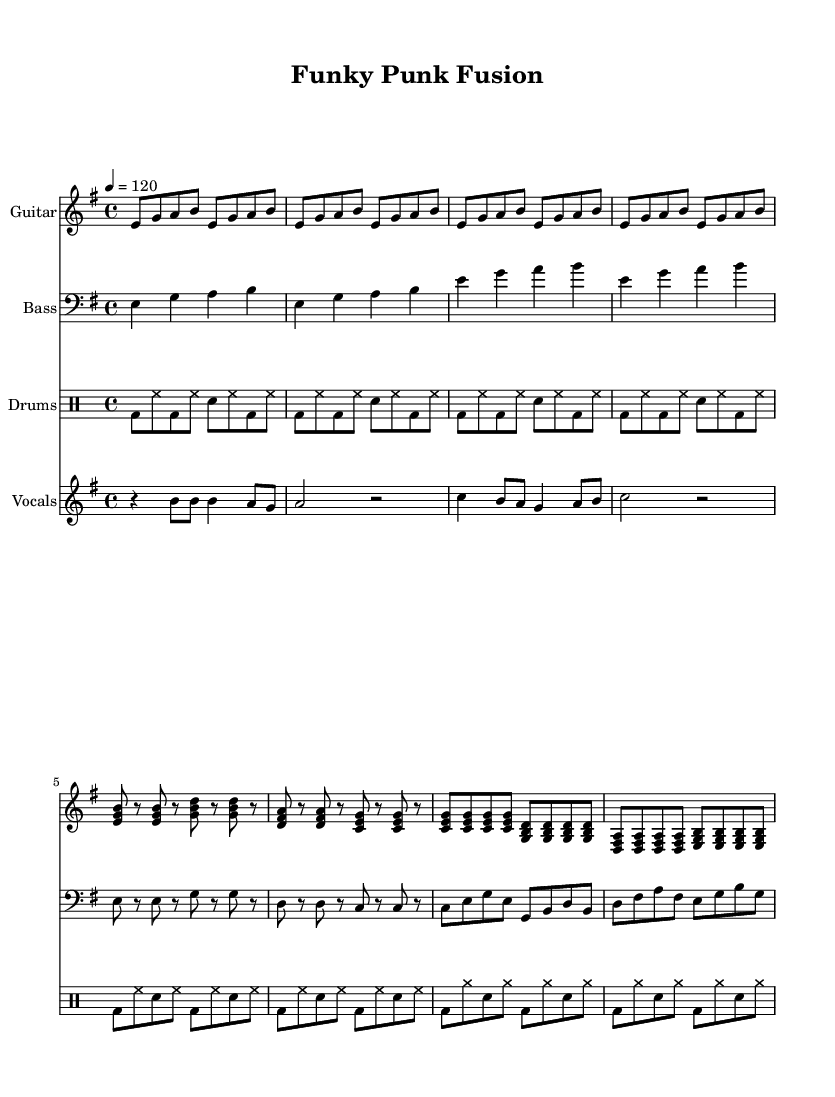What is the key signature of this music? The key signature is E minor, which has one sharp (F#). This can be determined from the key indication in the global section of the code, where it states "\key e \minor".
Answer: E minor What is the time signature of this music? The time signature is 4/4, which means there are four beats in each measure and the quarter note gets one beat. This is specified in the global section with "\time 4/4".
Answer: 4/4 What is the tempo marking? The tempo marking is 120 beats per minute. This is shown in the global section where it says "\tempo 4 = 120", indicating the speed of the music.
Answer: 120 What type of drum pattern is used in the song? The song uses a standard rock drum pattern. This is indicated in the drumPattern section and appears as a repetitive sequence combining bass drum (bd) and snare (sn) hits typical of rock music.
Answer: Standard rock pattern Which instrument plays the main riff in this funk-rock fusion? The guitar plays the main riff in the funk-rock fusion. The guitarRiff section indicates the distinctive riff that carries the energetic feel typical of funk music.
Answer: Guitar How does the bass line relate to the rhythm of the drums? The bass line complements the rhythm of the drums by playing steady quarter notes, complementing the upbeat eighth notes in the drumPattern. This creates a syncopated rhythm typical in funk music, enhancing the groove.
Answer: They complement each other 